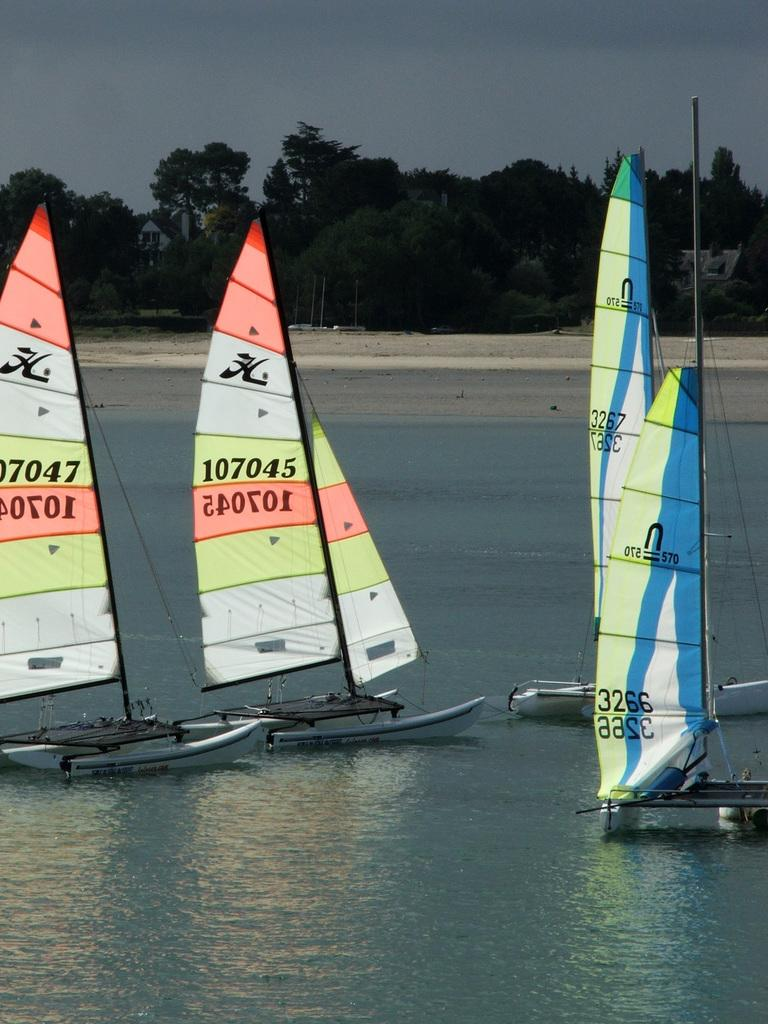What is the main subject of the image? The main subject of the image is boats. Where are the boats located? The boats are on the water. What can be seen in the background of the image? There are trees and the sky visible in the background of the image. What type of pig can be seen riding on the train in the image? There is no pig or train present in the image; it features boats on the water with trees and the sky in the background. 